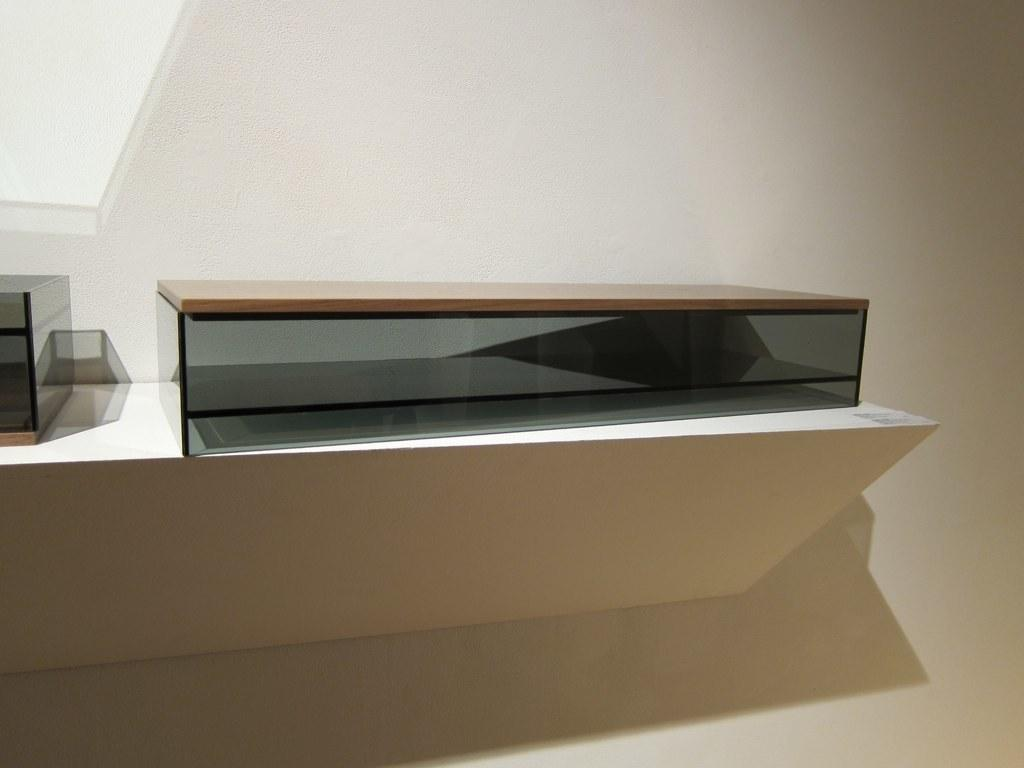What is the main object in the center of the image? There is a desk in the center of the image. What can be found on top of the desk? There is a glass object on the desk. What color is the wall in the image? The wall in the image is white. Where is the doll placed in relation to the desk in the image? There is no doll present in the image. What type of cheese can be seen on the glass object in the image? There is no cheese present in the image. 